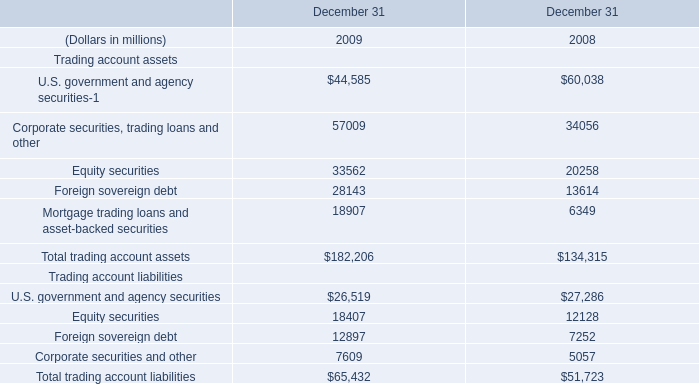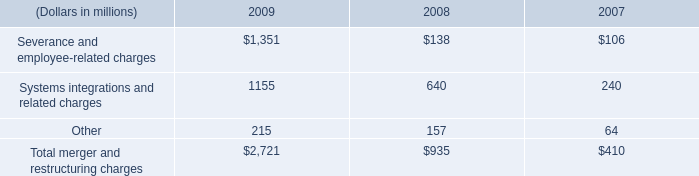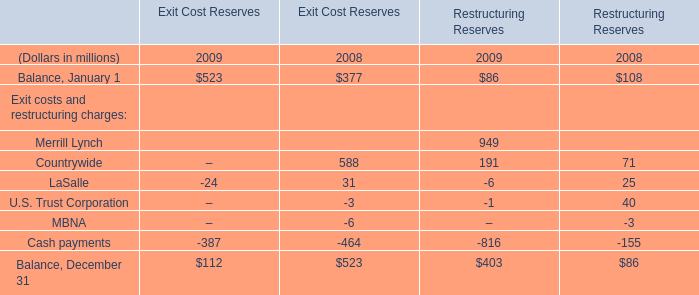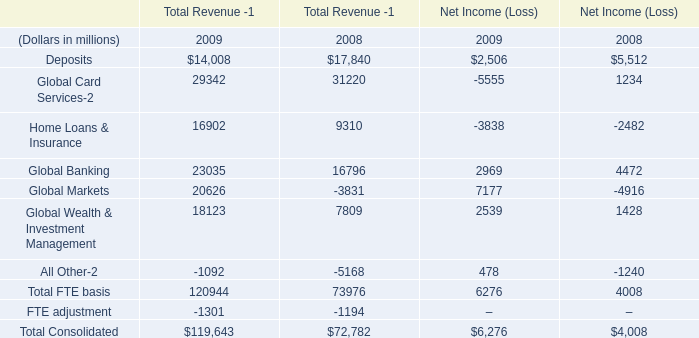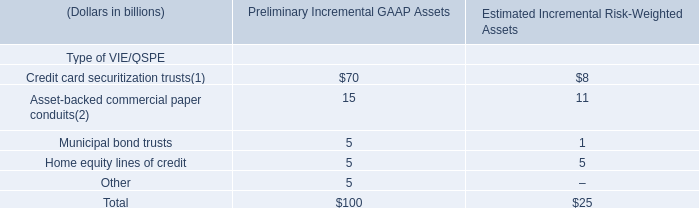In which year the Total trading account assets is positive? 
Answer: 2009. 